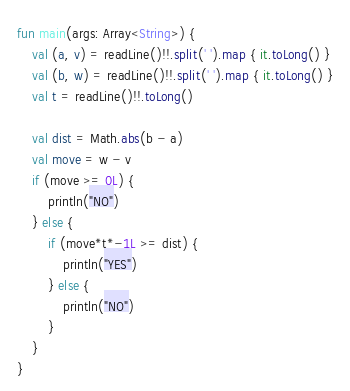<code> <loc_0><loc_0><loc_500><loc_500><_Kotlin_>fun main(args: Array<String>) {
    val (a, v) = readLine()!!.split(' ').map { it.toLong() }
    val (b, w) = readLine()!!.split(' ').map { it.toLong() }
    val t = readLine()!!.toLong()

    val dist = Math.abs(b - a)
    val move = w - v
    if (move >= 0L) {
        println("NO")
    } else {
        if (move*t*-1L >= dist) {
            println("YES")
        } else {
            println("NO")
        }
    }
}
</code> 